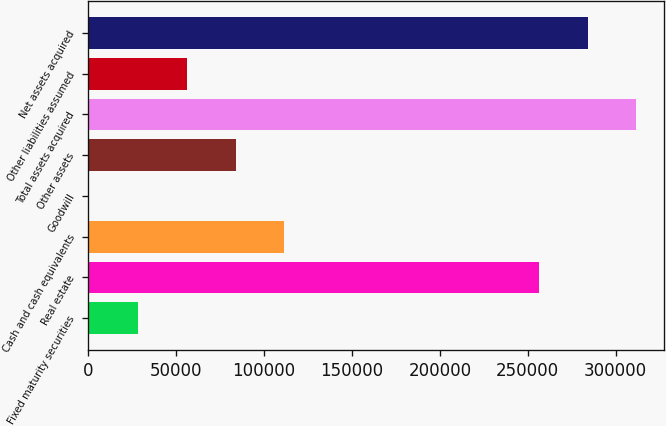<chart> <loc_0><loc_0><loc_500><loc_500><bar_chart><fcel>Fixed maturity securities<fcel>Real estate<fcel>Cash and cash equivalents<fcel>Goodwill<fcel>Other assets<fcel>Total assets acquired<fcel>Other liabilities assumed<fcel>Net assets acquired<nl><fcel>28067<fcel>256209<fcel>111515<fcel>251<fcel>83699<fcel>311841<fcel>55883<fcel>284025<nl></chart> 